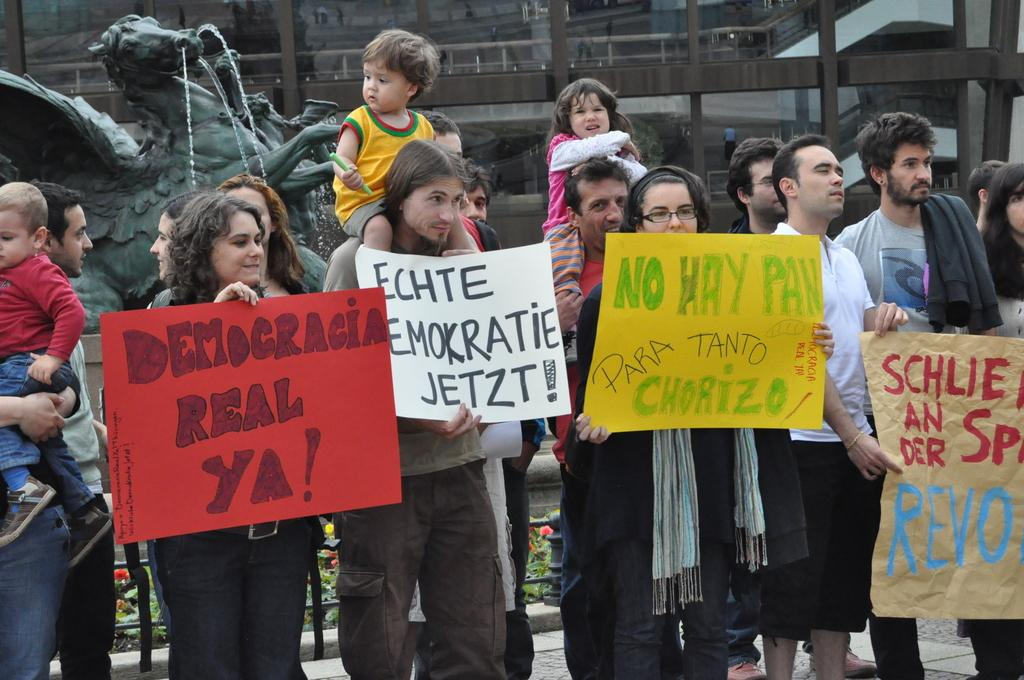How many people are in the image? There are people in the image, but the exact number is not specified. What are some of the people holding in the image? Some of the people are holding text boards in the image. What can be seen in the background of the image? There is a monument and a building in the background of the image. What type of rake is being used by the people in the image? There is no rake present in the image. Can you describe the argument taking place between the people in the image? There is no argument depicted in the image; the people are holding text boards. 